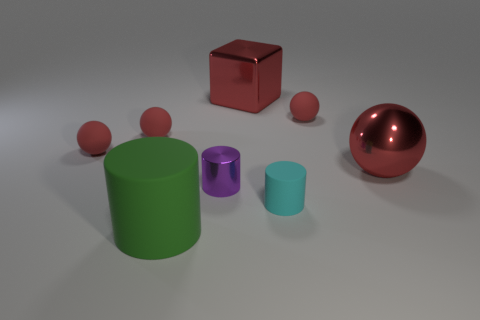Does the purple object that is behind the cyan cylinder have the same material as the block?
Ensure brevity in your answer.  Yes. What is the size of the green object?
Offer a very short reply. Large. There is a big shiny object that is the same color as the metallic ball; what is its shape?
Offer a terse response. Cube. How many balls are matte things or blue rubber things?
Ensure brevity in your answer.  3. Are there the same number of tiny red rubber spheres right of the tiny purple metallic object and matte objects behind the big red block?
Provide a succinct answer. No. The cyan thing that is the same shape as the small purple metal object is what size?
Your answer should be compact. Small. What size is the metal object that is in front of the large red metallic cube and behind the purple shiny thing?
Give a very brief answer. Large. Are there any small cyan matte cylinders behind the purple metallic object?
Offer a terse response. No. How many things are red spheres behind the large metal ball or cyan matte cylinders?
Ensure brevity in your answer.  4. There is a tiny red rubber ball that is to the right of the big green cylinder; how many cubes are in front of it?
Provide a short and direct response. 0. 